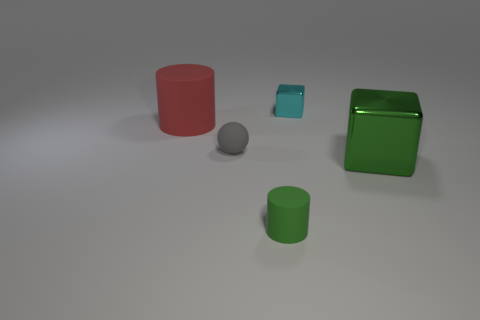Add 4 blue cylinders. How many objects exist? 9 Subtract all blocks. How many objects are left? 3 Add 4 metal things. How many metal things are left? 6 Add 4 tiny red metal things. How many tiny red metal things exist? 4 Subtract 0 blue spheres. How many objects are left? 5 Subtract all large yellow shiny blocks. Subtract all red rubber cylinders. How many objects are left? 4 